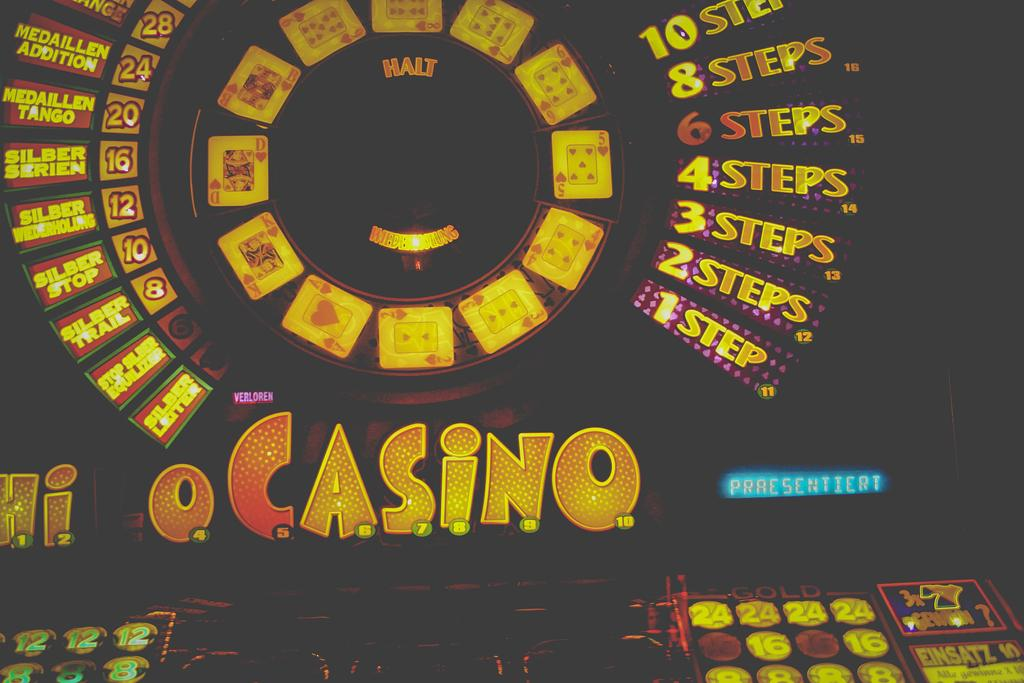<image>
Summarize the visual content of the image. The interface of a machine with the words casino in orange lights. 